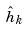<formula> <loc_0><loc_0><loc_500><loc_500>\hat { h } _ { k }</formula> 